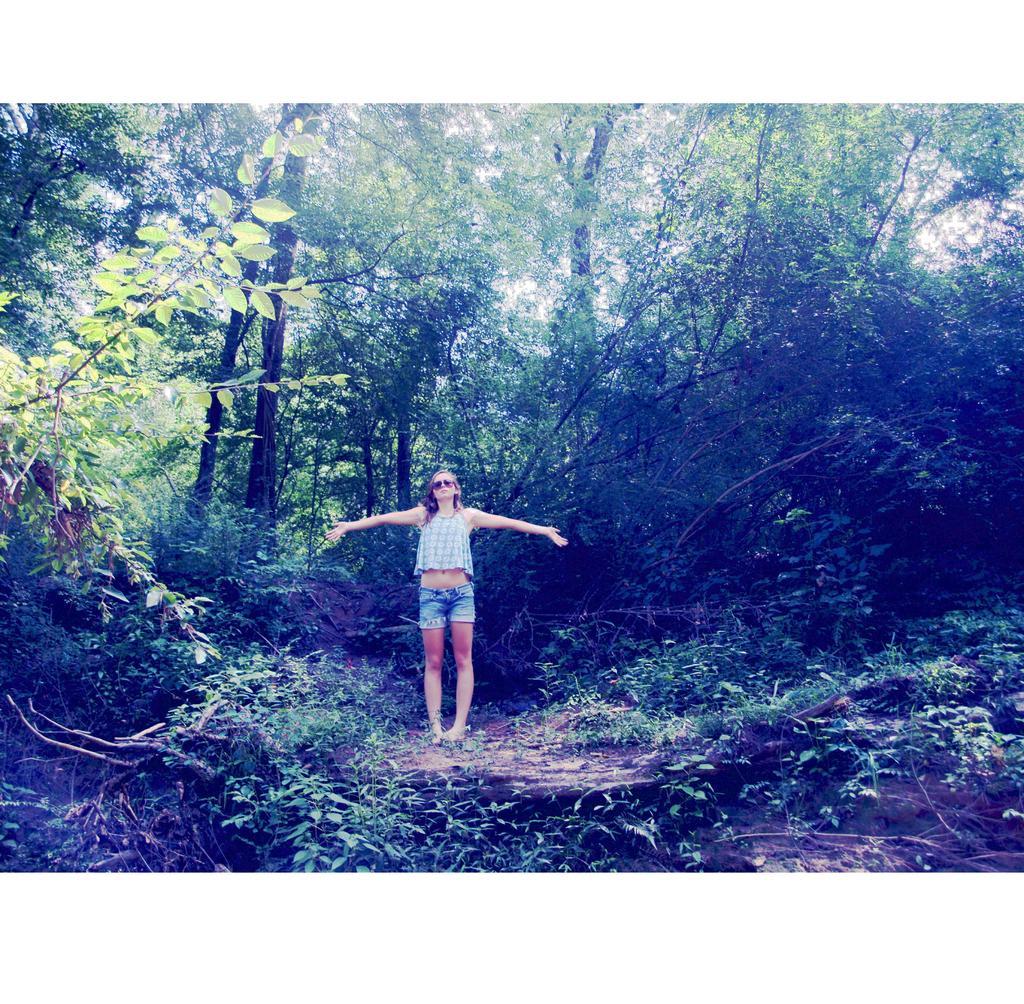Could you give a brief overview of what you see in this image? In this image there is a woman standing, she is wearing goggles, there are trees towards the top of the images, there are plants towards the bottom of the image. 